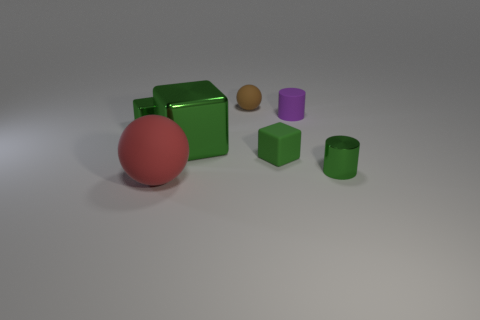Add 3 small green rubber cubes. How many objects exist? 10 Subtract all balls. How many objects are left? 5 Add 2 small brown things. How many small brown things exist? 3 Subtract 0 purple blocks. How many objects are left? 7 Subtract all green objects. Subtract all green matte objects. How many objects are left? 2 Add 4 large red rubber spheres. How many large red rubber spheres are left? 5 